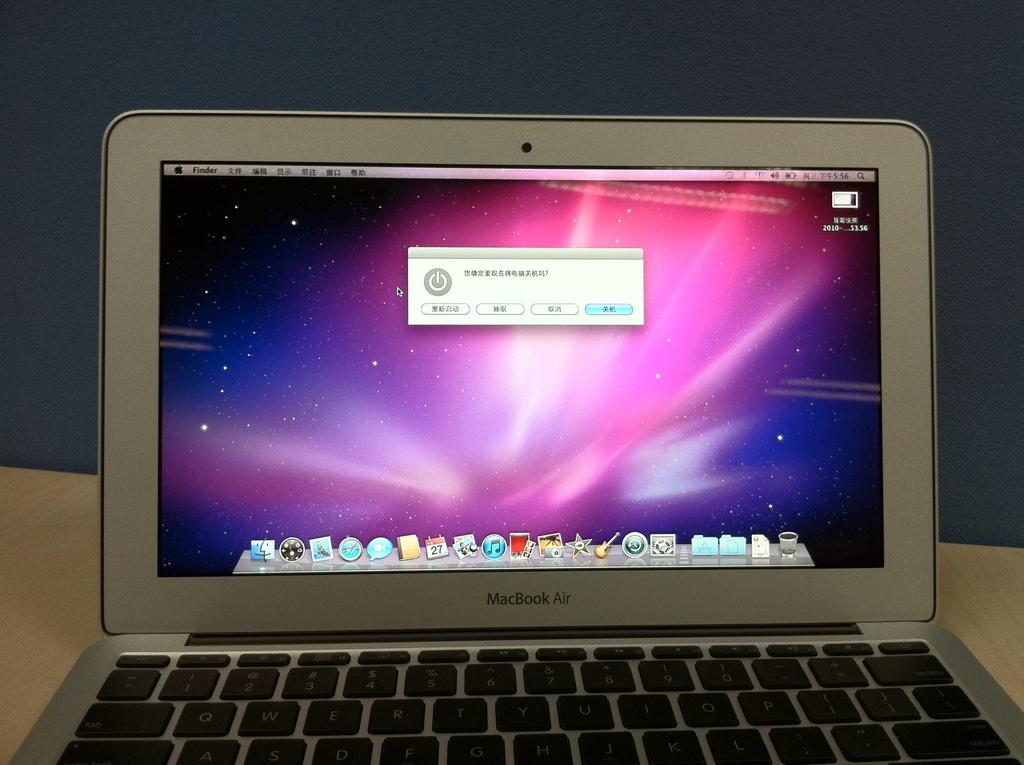What is placed on the table in the image? There is a laptop placed on a table. Can you describe the setting where the laptop is located? The laptop is located on a table, which suggests it might be in a workspace or study area. What type of attraction can be seen in the background of the image? There is no attraction visible in the image; it only features a laptop placed on a table. What type of farm animals can be seen grazing on the cabbage in the image? There are no farm animals or cabbage present in the image. 